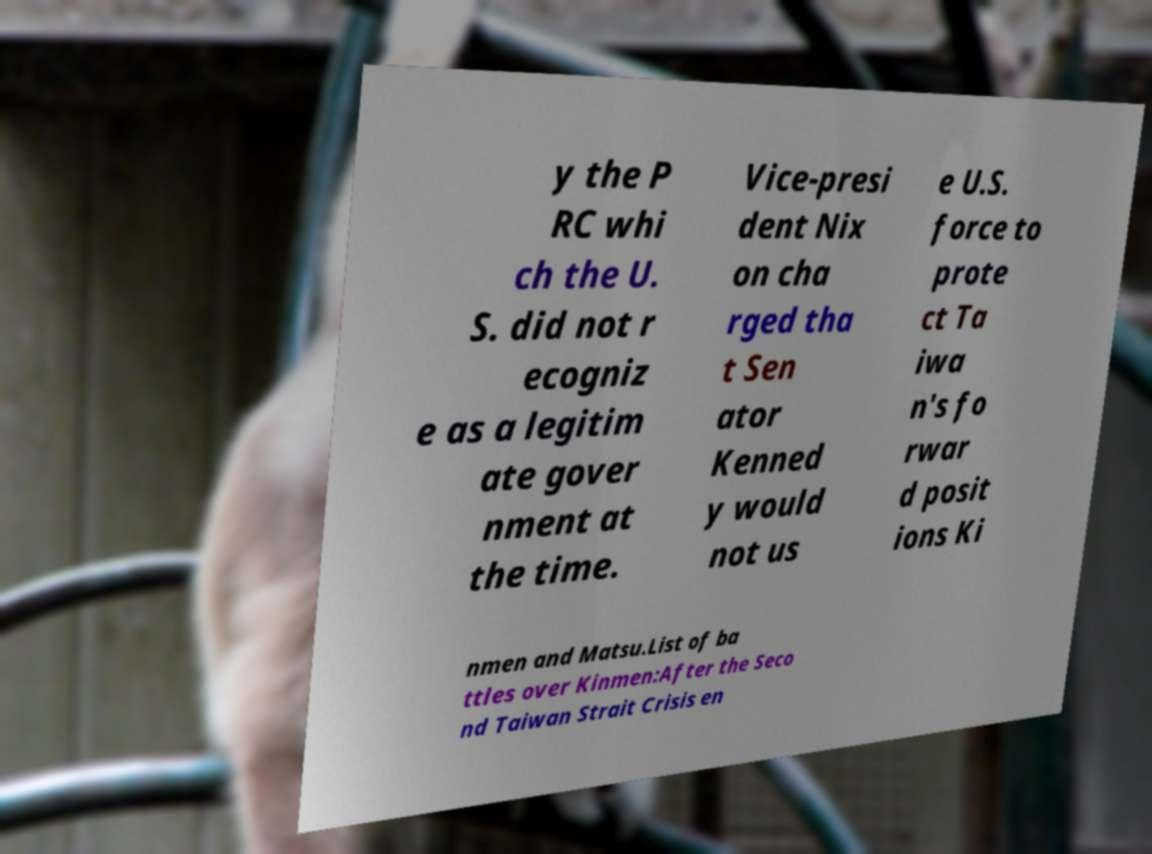Can you read and provide the text displayed in the image?This photo seems to have some interesting text. Can you extract and type it out for me? y the P RC whi ch the U. S. did not r ecogniz e as a legitim ate gover nment at the time. Vice-presi dent Nix on cha rged tha t Sen ator Kenned y would not us e U.S. force to prote ct Ta iwa n's fo rwar d posit ions Ki nmen and Matsu.List of ba ttles over Kinmen:After the Seco nd Taiwan Strait Crisis en 